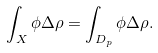<formula> <loc_0><loc_0><loc_500><loc_500>\int _ { X } \phi \Delta \rho = \int _ { D _ { p } } \phi \Delta \rho .</formula> 